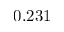Convert formula to latex. <formula><loc_0><loc_0><loc_500><loc_500>0 . 2 3 1</formula> 